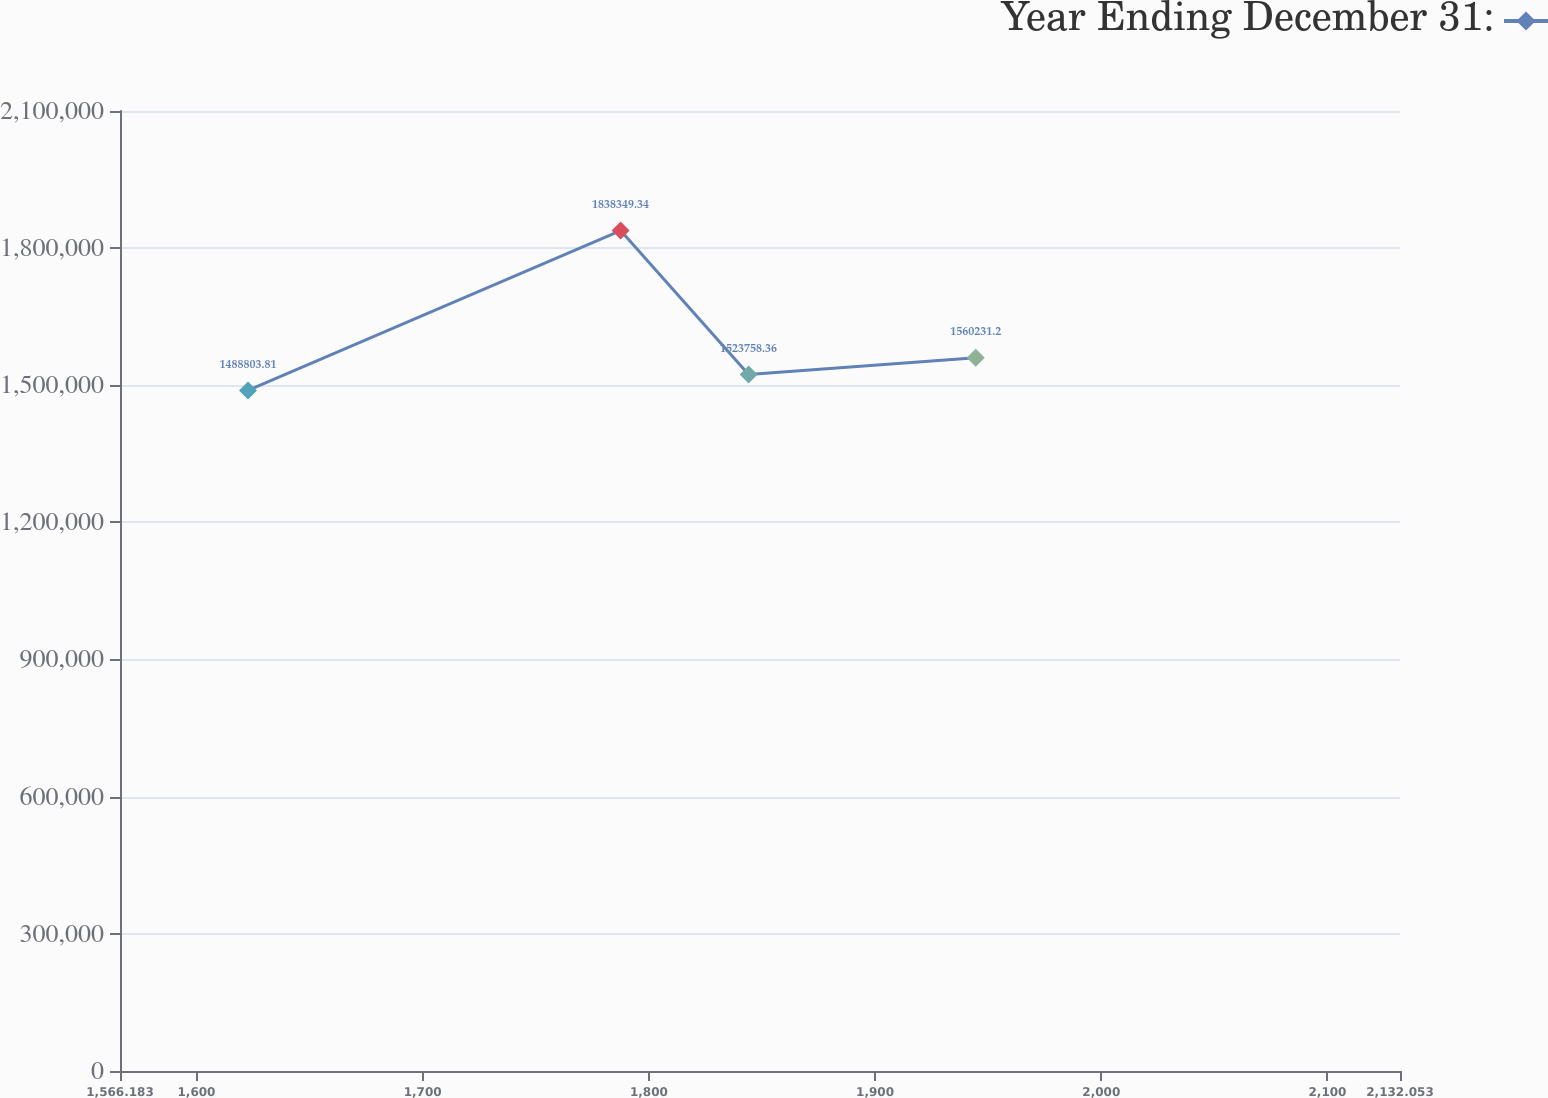Convert chart to OTSL. <chart><loc_0><loc_0><loc_500><loc_500><line_chart><ecel><fcel>Year Ending December 31:<nl><fcel>1622.77<fcel>1.4888e+06<nl><fcel>1787.49<fcel>1.83835e+06<nl><fcel>1844.08<fcel>1.52376e+06<nl><fcel>1944.49<fcel>1.56023e+06<nl><fcel>2188.64<fcel>1.64707e+06<nl></chart> 